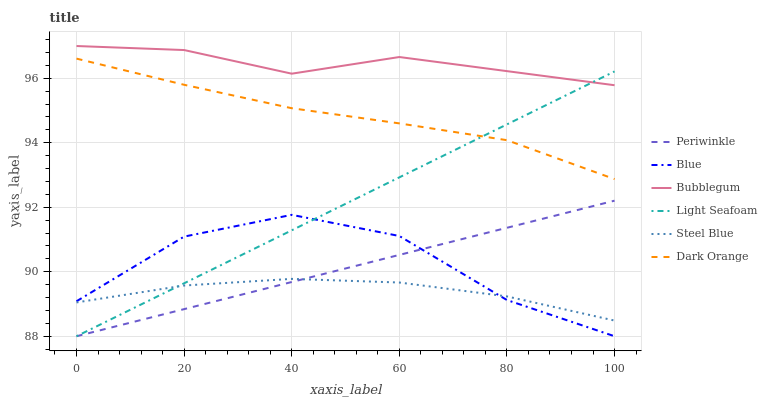Does Steel Blue have the minimum area under the curve?
Answer yes or no. Yes. Does Bubblegum have the maximum area under the curve?
Answer yes or no. Yes. Does Dark Orange have the minimum area under the curve?
Answer yes or no. No. Does Dark Orange have the maximum area under the curve?
Answer yes or no. No. Is Light Seafoam the smoothest?
Answer yes or no. Yes. Is Blue the roughest?
Answer yes or no. Yes. Is Dark Orange the smoothest?
Answer yes or no. No. Is Dark Orange the roughest?
Answer yes or no. No. Does Blue have the lowest value?
Answer yes or no. Yes. Does Dark Orange have the lowest value?
Answer yes or no. No. Does Bubblegum have the highest value?
Answer yes or no. Yes. Does Dark Orange have the highest value?
Answer yes or no. No. Is Steel Blue less than Bubblegum?
Answer yes or no. Yes. Is Dark Orange greater than Blue?
Answer yes or no. Yes. Does Light Seafoam intersect Dark Orange?
Answer yes or no. Yes. Is Light Seafoam less than Dark Orange?
Answer yes or no. No. Is Light Seafoam greater than Dark Orange?
Answer yes or no. No. Does Steel Blue intersect Bubblegum?
Answer yes or no. No. 